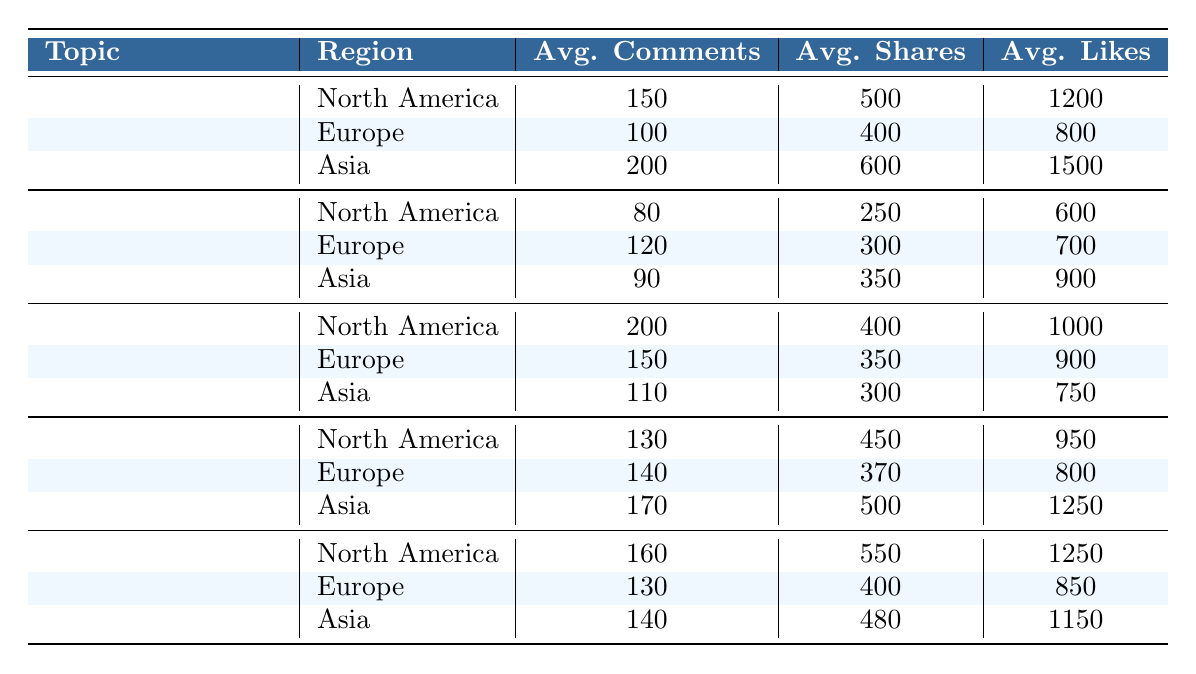What is the average number of comments on Technology blogs in Asia? The table indicates that the average number of comments on Technology blogs in Asia is listed directly, which is 200.
Answer: 200 Which region has the highest average likes for Health & Fitness blogs? In the table, for Health & Fitness blogs, North America has an average of 950 likes, Europe has 800, and Asia has 1250 likes. Among these, Asia has the highest value at 1250.
Answer: Asia What is the difference in average shares between Travel blogs in North America and Europe? The average shares for Travel blogs in North America is 250, while for Europe it is 300. The difference is calculated as 300 - 250 = 50.
Answer: 50 Is it true that the average likes for Food & Cooking blogs in North America are greater than those in Asia? According to the table, Food & Cooking blogs in North America have 1250 likes, whereas in Asia, they have 1150 likes. Since 1250 is greater than 1150, the statement is true.
Answer: Yes What is the total average number of comments for all blog topics in North America? To find the total, we add the average comments for each topic in North America: Technology (150) + Travel (80) + Lifestyle (200) + Health & Fitness (130) + Food & Cooking (160) = 720.
Answer: 720 Which blog topic has the lowest average shares in Europe? The table shows that the average shares for each topic in Europe are Technology (400), Travel (300), Lifestyle (350), Health & Fitness (370), and Food & Cooking (400). Travel has the lowest average shares at 300.
Answer: Travel What is the highest average number of comments across all regions and topics? Scanning through the table, the highest average number of comments is found under Technology in Asia with 200. This is verified against all other averages for comments across various topics.
Answer: 200 What is the average number of likes for Lifestyle blogs in Europe compared to those in Asia? The average likes for Lifestyle blogs in Europe is 900, while in Asia it is 750. Comparing these figures shows that Europe has a higher average of 900 likes than Asia’s 750 likes.
Answer: Europe has more likes 